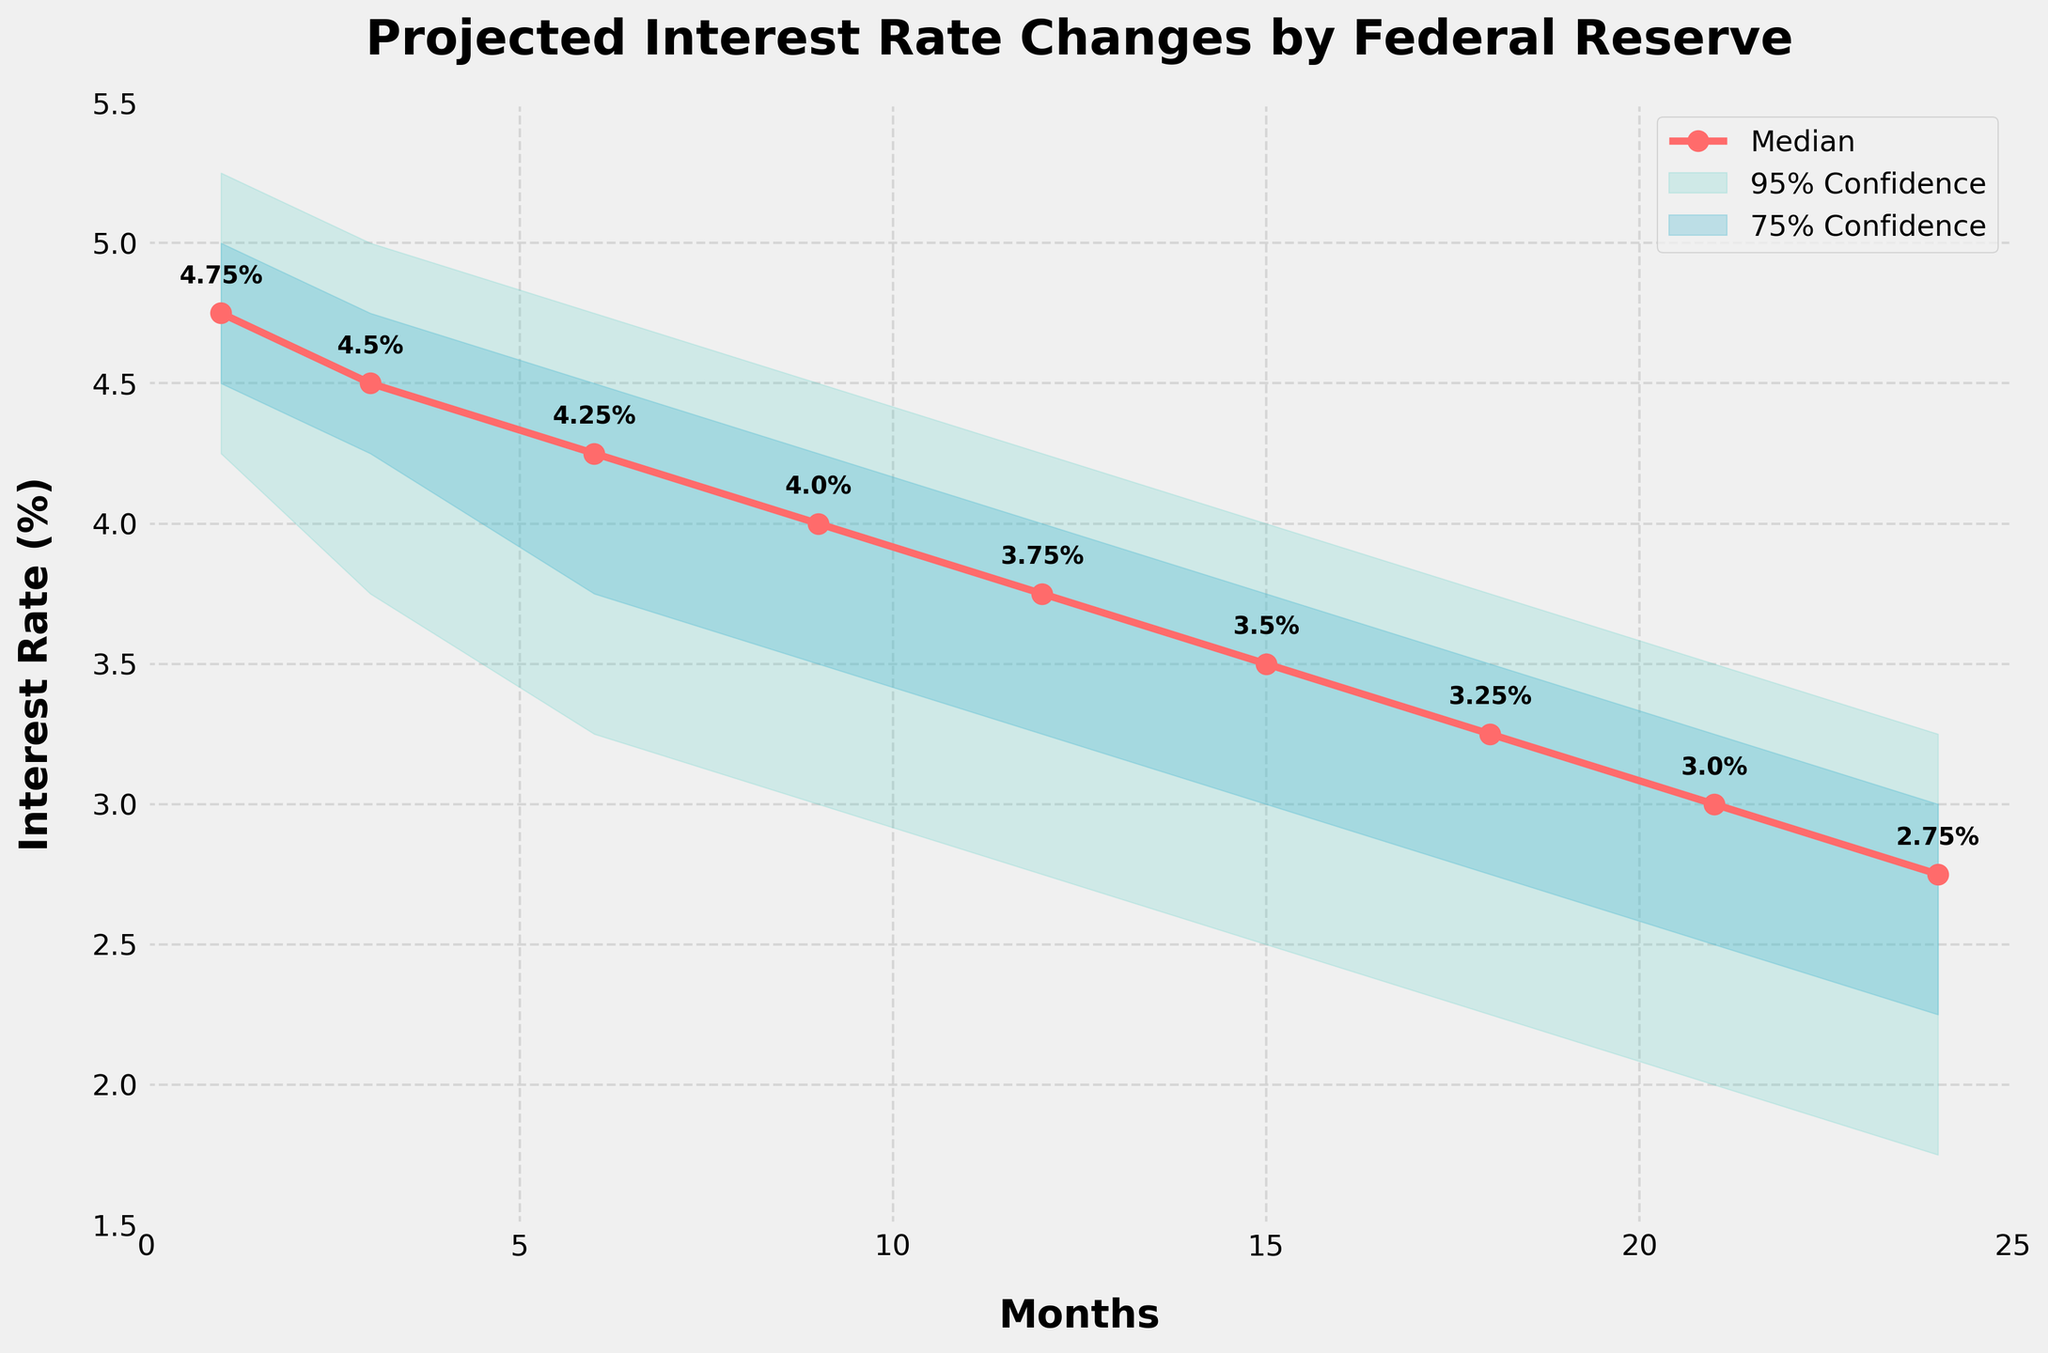What is the title of the chart? The title of the chart is displayed at the top, it helps in understanding the main subject of the visualization.
Answer: Projected Interest Rate Changes by Federal Reserve What is the median interest rate projected for month 12? The median interest rate for each month is indicated by the red line with circle markers, and specifically for month 12, you can find the label next to the marker.
Answer: 3.75% What is the range of the 95% confidence interval for month 6? The 95% confidence interval range for month 6 is shown by the shaded area extending from the lower to the upper bound value for that month.
Answer: 3.25% to 4.75% During which month does the median interest rate first fall below 4%? By examining the red median line, it is observed that it dips below 4% for the first time. Month identifiers can be cross-referenced with the median rate.
Answer: Month 9 How does the width of the 95% confidence interval change over time? The width of the 95% confidence interval can be assessed by looking at the extent of the light green shaded area across different months.
Answer: It generally widens over time How does the uncertainty range change from month 1 to month 24? Comparing the shaded areas representing uncertainty from month 1 to month 24 gives an idea of how uncertainty evolves over the period.
Answer: Uncertainty increases over time What is the difference between the upper and lower bounds of the 75% confidence interval in month 3? The 75% confidence interval in month 3 extends from its lower bound to the upper bound, the difference provides the range.
Answer: 0.50% (4.75% - 4.25%) Compare the median interest rates between month 1 and month 24. The median interest rates for specific months are shown as data labels next to the markers on the red line. Evaluating months 1 and 24’s medians provides the comparison.
Answer: Month 1: 4.75%, Month 24: 2.75% In which month is the highest median interest rate projected? The highest point on the red median line indicates the month with the max median interest rate, cross-referenced with the month value.
Answer: Month 1 How much does the median interest rate decrease from month 1 to month 6? Subtract the median interest rate at month 6 from that at month 1 to find the change.
Answer: 0.5% (4.75% - 4.25%) 